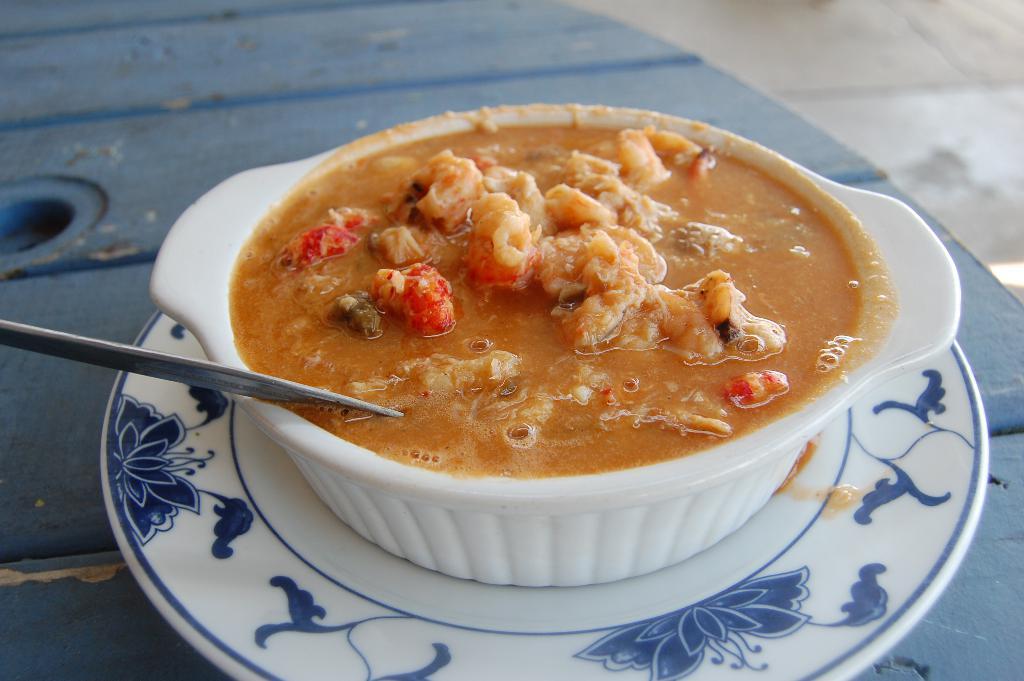Please provide a concise description of this image. This image contains a plate on the table. On plate there is a bowl having some food and spoon in it. Bedside table there is floor. 